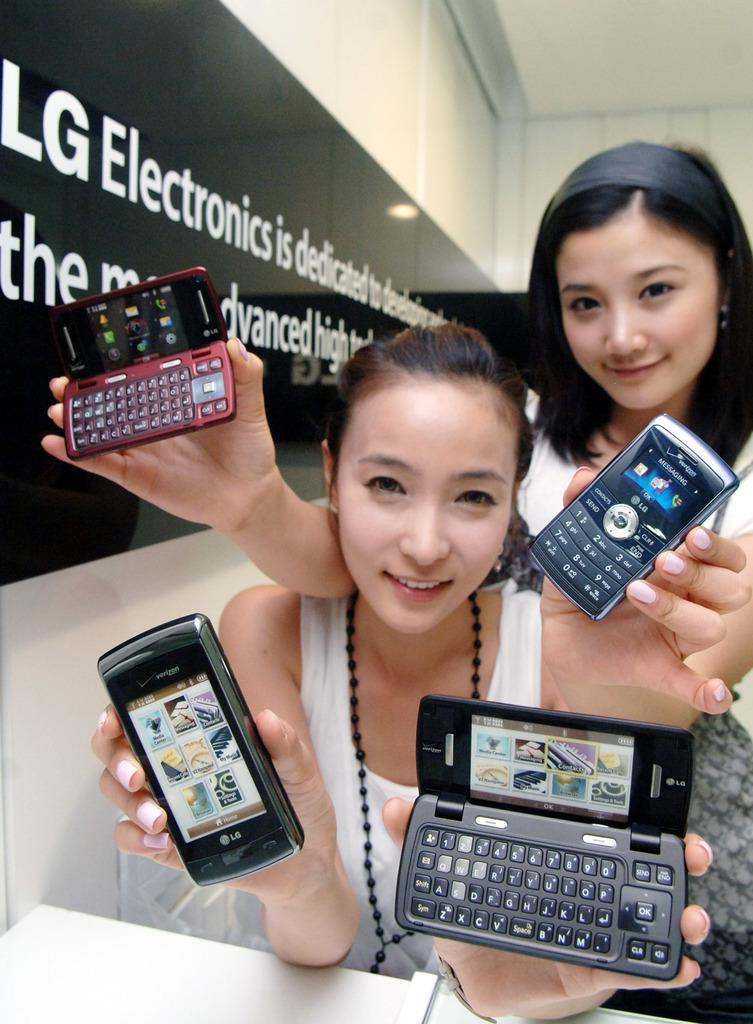Provide a one-sentence caption for the provided image. 2 models holding 4 different lg phones and a lg banner/sign in the background. 